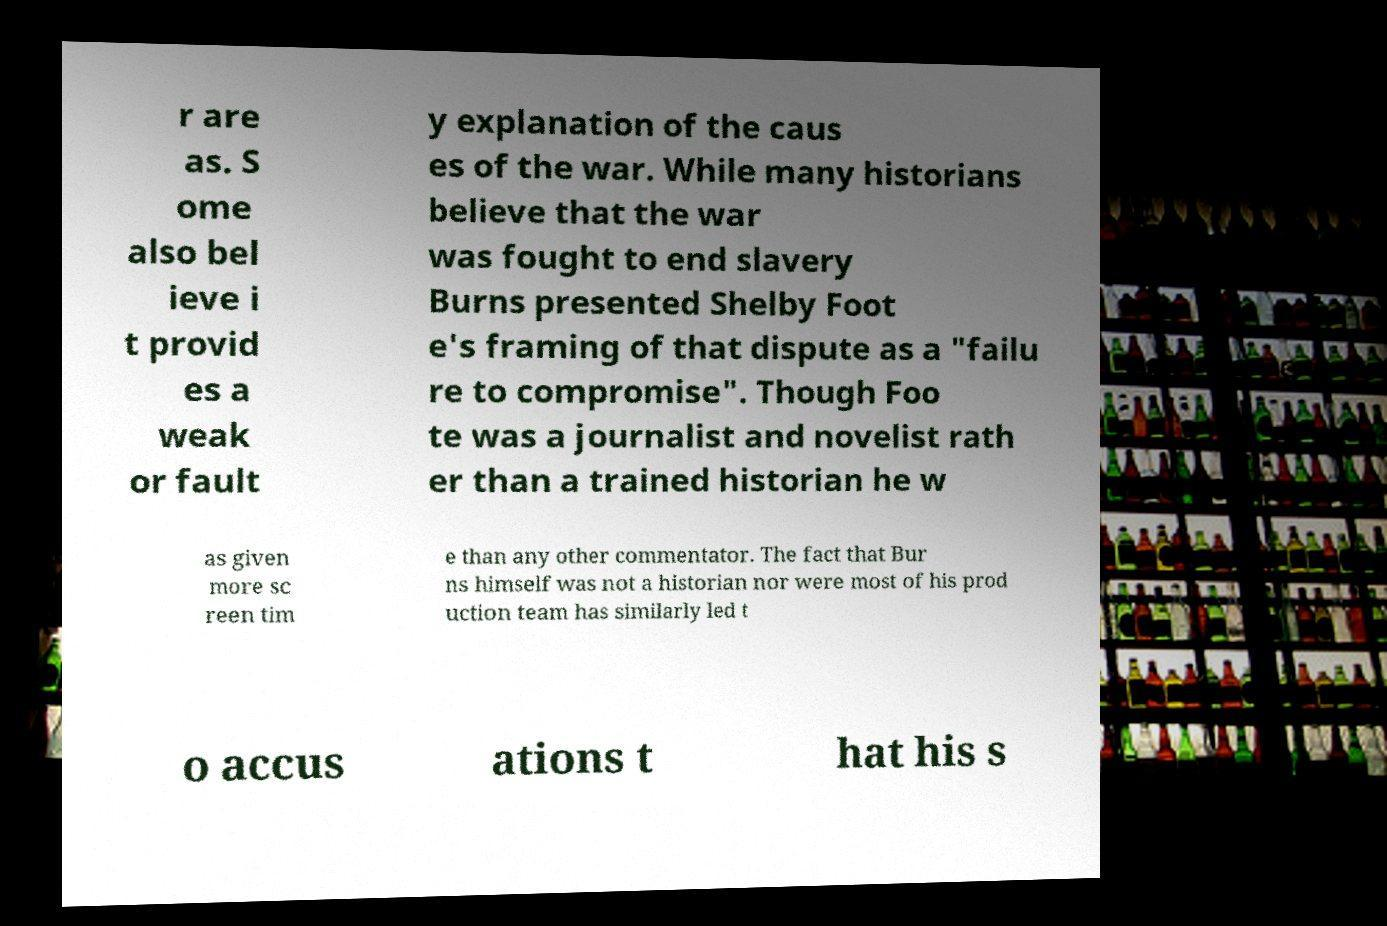Could you assist in decoding the text presented in this image and type it out clearly? r are as. S ome also bel ieve i t provid es a weak or fault y explanation of the caus es of the war. While many historians believe that the war was fought to end slavery Burns presented Shelby Foot e's framing of that dispute as a "failu re to compromise". Though Foo te was a journalist and novelist rath er than a trained historian he w as given more sc reen tim e than any other commentator. The fact that Bur ns himself was not a historian nor were most of his prod uction team has similarly led t o accus ations t hat his s 